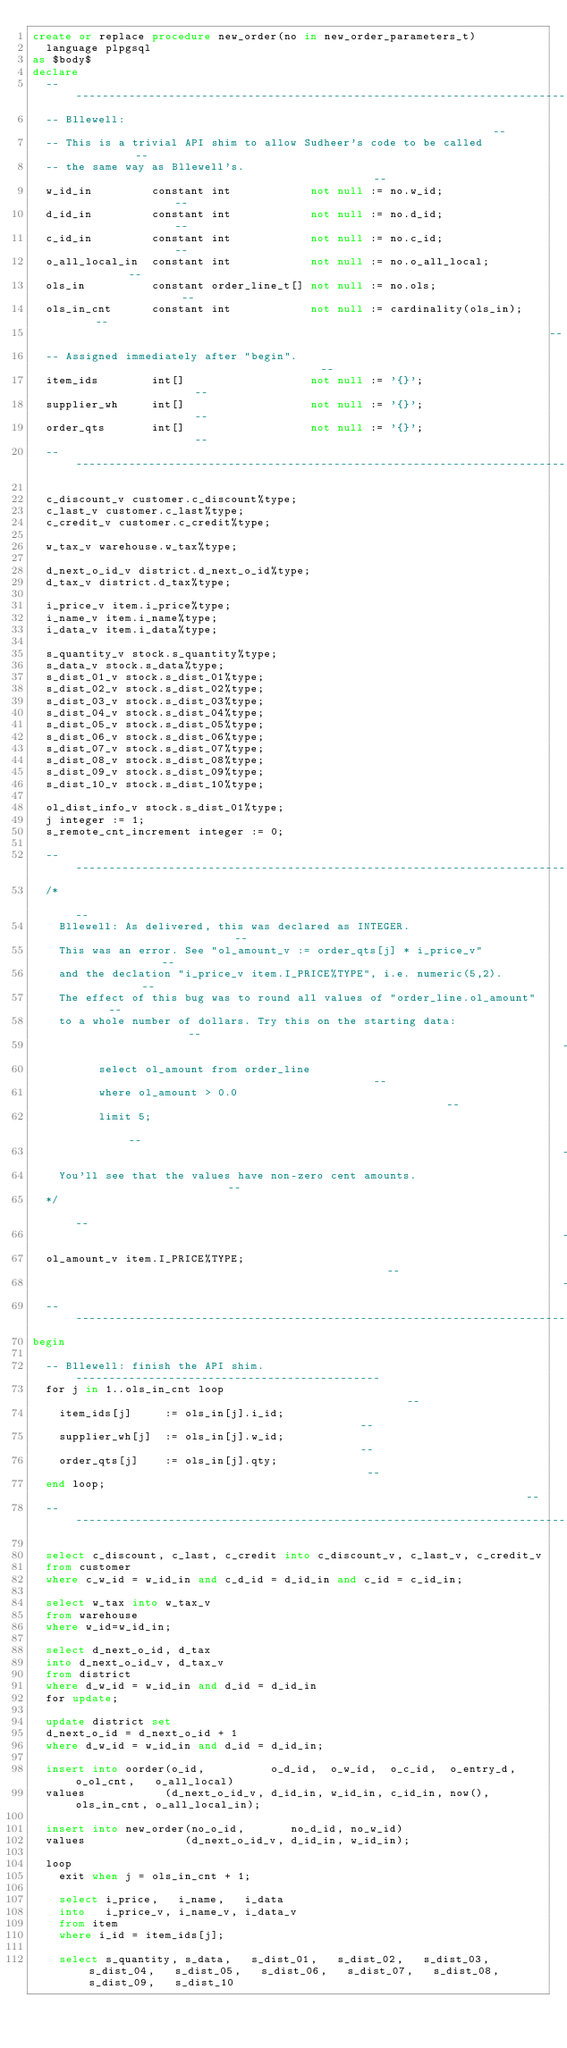Convert code to text. <code><loc_0><loc_0><loc_500><loc_500><_SQL_>create or replace procedure new_order(no in new_order_parameters_t)
  language plpgsql
as $body$
declare
  ------------------------------------------------------------------------------
  -- Bllewell:                                                                --
  -- This is a trivial API shim to allow Sudheer's code to be called          --
  -- the same way as Bllewell's.                                              --
  w_id_in         constant int            not null := no.w_id;                --
  d_id_in         constant int            not null := no.d_id;                --
  c_id_in         constant int            not null := no.c_id;                --
  o_all_local_in  constant int            not null := no.o_all_local;         --
  ols_in          constant order_line_t[] not null := no.ols;                 --
  ols_in_cnt      constant int            not null := cardinality(ols_in);    --
                                                                              --
  -- Assigned immediately after "begin".                                      --
  item_ids        int[]                   not null := '{}';                   --
  supplier_wh     int[]                   not null := '{}';                   --
  order_qts       int[]                   not null := '{}';                   --
  ------------------------------------------------------------------------------

  c_discount_v customer.c_discount%type;
  c_last_v customer.c_last%type;
  c_credit_v customer.c_credit%type;

  w_tax_v warehouse.w_tax%type;

  d_next_o_id_v district.d_next_o_id%type;
  d_tax_v district.d_tax%type;

  i_price_v item.i_price%type;
  i_name_v item.i_name%type;
  i_data_v item.i_data%type;

  s_quantity_v stock.s_quantity%type;
  s_data_v stock.s_data%type;
  s_dist_01_v stock.s_dist_01%type;
  s_dist_02_v stock.s_dist_02%type;
  s_dist_03_v stock.s_dist_03%type;
  s_dist_04_v stock.s_dist_04%type;
  s_dist_05_v stock.s_dist_05%type;
  s_dist_06_v stock.s_dist_06%type;
  s_dist_07_v stock.s_dist_07%type;
  s_dist_08_v stock.s_dist_08%type;
  s_dist_09_v stock.s_dist_09%type;
  s_dist_10_v stock.s_dist_10%type;

  ol_dist_info_v stock.s_dist_01%type;
  j integer := 1;
  s_remote_cnt_increment integer := 0;

  --------------------------------------------------------------------------------
  /*                                                                            --
    Bllewell: As delivered, this was declared as INTEGER.                       --
    This was an error. See "ol_amount_v := order_qts[j] * i_price_v"            --
    and the declation "i_price_v item.I_PRICE%TYPE", i.e. numeric(5,2).         --
    The effect of this bug was to round all values of "order_line.ol_amount"    --
    to a whole number of dollars. Try this on the starting data:                --
                                                                                --
          select ol_amount from order_line                                      --
          where ol_amount > 0.0                                                 --
          limit 5;                                                              --
                                                                                --
    You'll see that the values have non-zero cent amounts.                      --
  */                                                                            --
                                                                                --
  ol_amount_v item.I_PRICE%TYPE;                                                --
                                                                                --
  --------------------------------------------------------------------------------
begin

  -- Bllewell: finish the API shim. ----------------------------------------------
  for j in 1..ols_in_cnt loop                                                   --
    item_ids[j]     := ols_in[j].i_id;                                          --
    supplier_wh[j]  := ols_in[j].w_id;                                          --
    order_qts[j]    := ols_in[j].qty;                                           --
  end loop;                                                                     --
  --------------------------------------------------------------------------------

  select c_discount, c_last, c_credit into c_discount_v, c_last_v, c_credit_v
  from customer
  where c_w_id = w_id_in and c_d_id = d_id_in and c_id = c_id_in;

  select w_tax into w_tax_v
  from warehouse
  where w_id=w_id_in;

  select d_next_o_id, d_tax
  into d_next_o_id_v, d_tax_v
  from district
  where d_w_id = w_id_in and d_id = d_id_in
  for update;

  update district set
  d_next_o_id = d_next_o_id + 1 
  where d_w_id = w_id_in and d_id = d_id_in;

  insert into oorder(o_id,          o_d_id,  o_w_id,  o_c_id,  o_entry_d, o_ol_cnt,   o_all_local)
  values            (d_next_o_id_v, d_id_in, w_id_in, c_id_in, now(),     ols_in_cnt, o_all_local_in);

  insert into new_order(no_o_id,       no_d_id, no_w_id)
  values               (d_next_o_id_v, d_id_in, w_id_in);

  loop
    exit when j = ols_in_cnt + 1;

    select i_price,   i_name,   i_data
    into   i_price_v, i_name_v, i_data_v
    from item
    where i_id = item_ids[j];

    select s_quantity, s_data,   s_dist_01,   s_dist_02,   s_dist_03,   s_dist_04,   s_dist_05,   s_dist_06,   s_dist_07,   s_dist_08,   s_dist_09,   s_dist_10</code> 